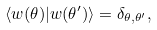<formula> <loc_0><loc_0><loc_500><loc_500>\langle w ( \theta ) | w ( \theta ^ { \prime } ) \rangle = \delta _ { \theta , \theta ^ { \prime } } ,</formula> 